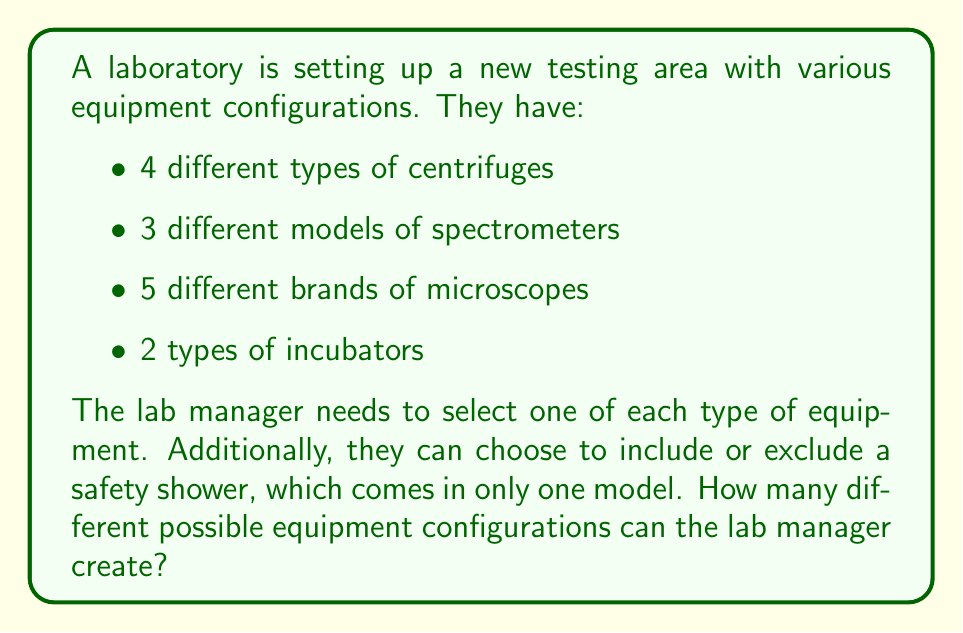Can you solve this math problem? To solve this problem, we'll use the multiplication principle of counting and consider the optional safety shower as a separate choice.

1. For each type of equipment, we have:
   - Centrifuges: 4 choices
   - Spectrometers: 3 choices
   - Microscopes: 5 choices
   - Incubators: 2 choices

2. The number of configurations without considering the safety shower is:
   $$ 4 \times 3 \times 5 \times 2 = 120 $$

3. For the safety shower, there are two possibilities:
   - Include the safety shower
   - Exclude the safety shower

4. To account for the safety shower option, we multiply our previous result by 2:
   $$ 120 \times 2 = 240 $$

Therefore, the total number of possible equipment configurations is 240.

This approach is based on the fundamental counting principle, which states that if we have $m$ ways of doing something and $n$ ways of doing another thing, there are $m \times n$ ways of doing both things.
Answer: The lab manager can create 240 different possible equipment configurations. 